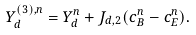<formula> <loc_0><loc_0><loc_500><loc_500>Y ^ { ( 3 ) , n } _ { d } = Y ^ { n } _ { d } + J _ { d , 2 } ( c _ { B } ^ { n } - c _ { E } ^ { n } ) .</formula> 